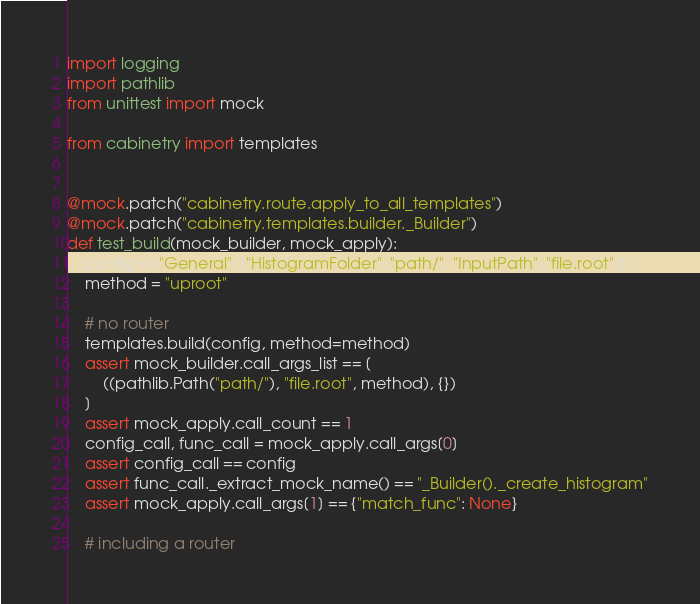<code> <loc_0><loc_0><loc_500><loc_500><_Python_>import logging
import pathlib
from unittest import mock

from cabinetry import templates


@mock.patch("cabinetry.route.apply_to_all_templates")
@mock.patch("cabinetry.templates.builder._Builder")
def test_build(mock_builder, mock_apply):
    config = {"General": {"HistogramFolder": "path/", "InputPath": "file.root"}}
    method = "uproot"

    # no router
    templates.build(config, method=method)
    assert mock_builder.call_args_list == [
        ((pathlib.Path("path/"), "file.root", method), {})
    ]
    assert mock_apply.call_count == 1
    config_call, func_call = mock_apply.call_args[0]
    assert config_call == config
    assert func_call._extract_mock_name() == "_Builder()._create_histogram"
    assert mock_apply.call_args[1] == {"match_func": None}

    # including a router</code> 